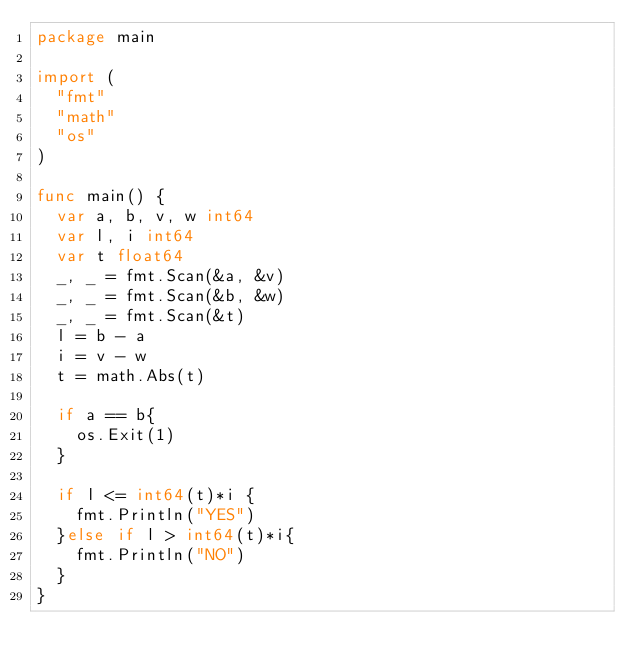<code> <loc_0><loc_0><loc_500><loc_500><_Go_>package main

import (
	"fmt"
	"math"
	"os"
)

func main() {
	var a, b, v, w int64
	var l, i int64
	var t float64
	_, _ = fmt.Scan(&a, &v)
	_, _ = fmt.Scan(&b, &w)
	_, _ = fmt.Scan(&t)
	l = b - a
	i = v - w
	t = math.Abs(t)
	
	if a == b{
		os.Exit(1)
	}
	
	if l <= int64(t)*i {
		fmt.Println("YES")
	}else if l > int64(t)*i{
		fmt.Println("NO")
	}
}</code> 